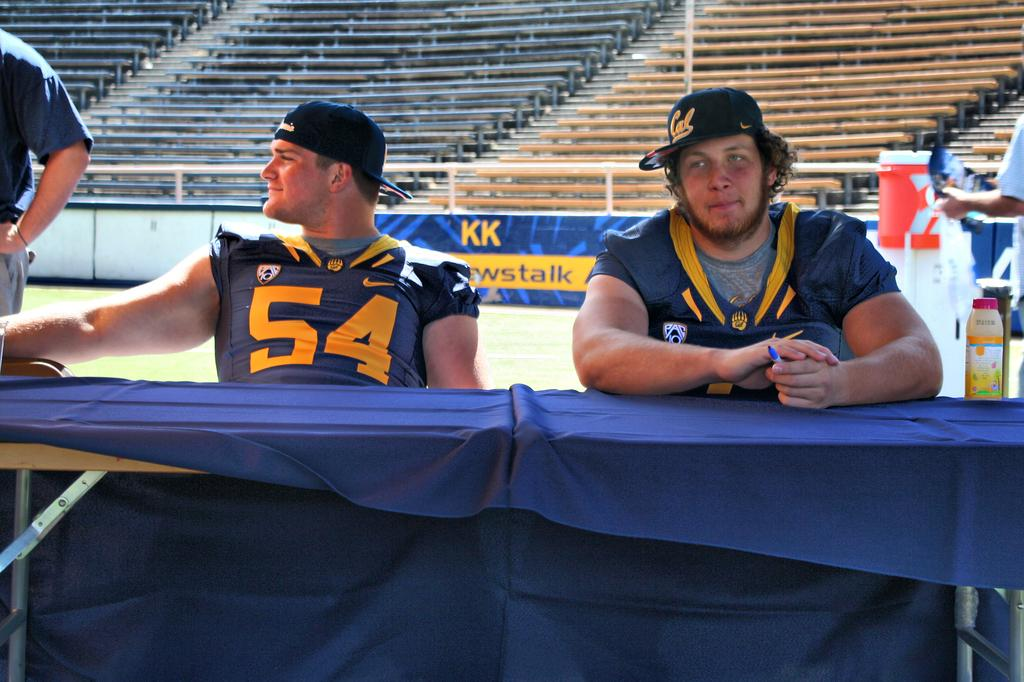<image>
Describe the image concisely. Player number 54 sits at a table near a sign that says KK 